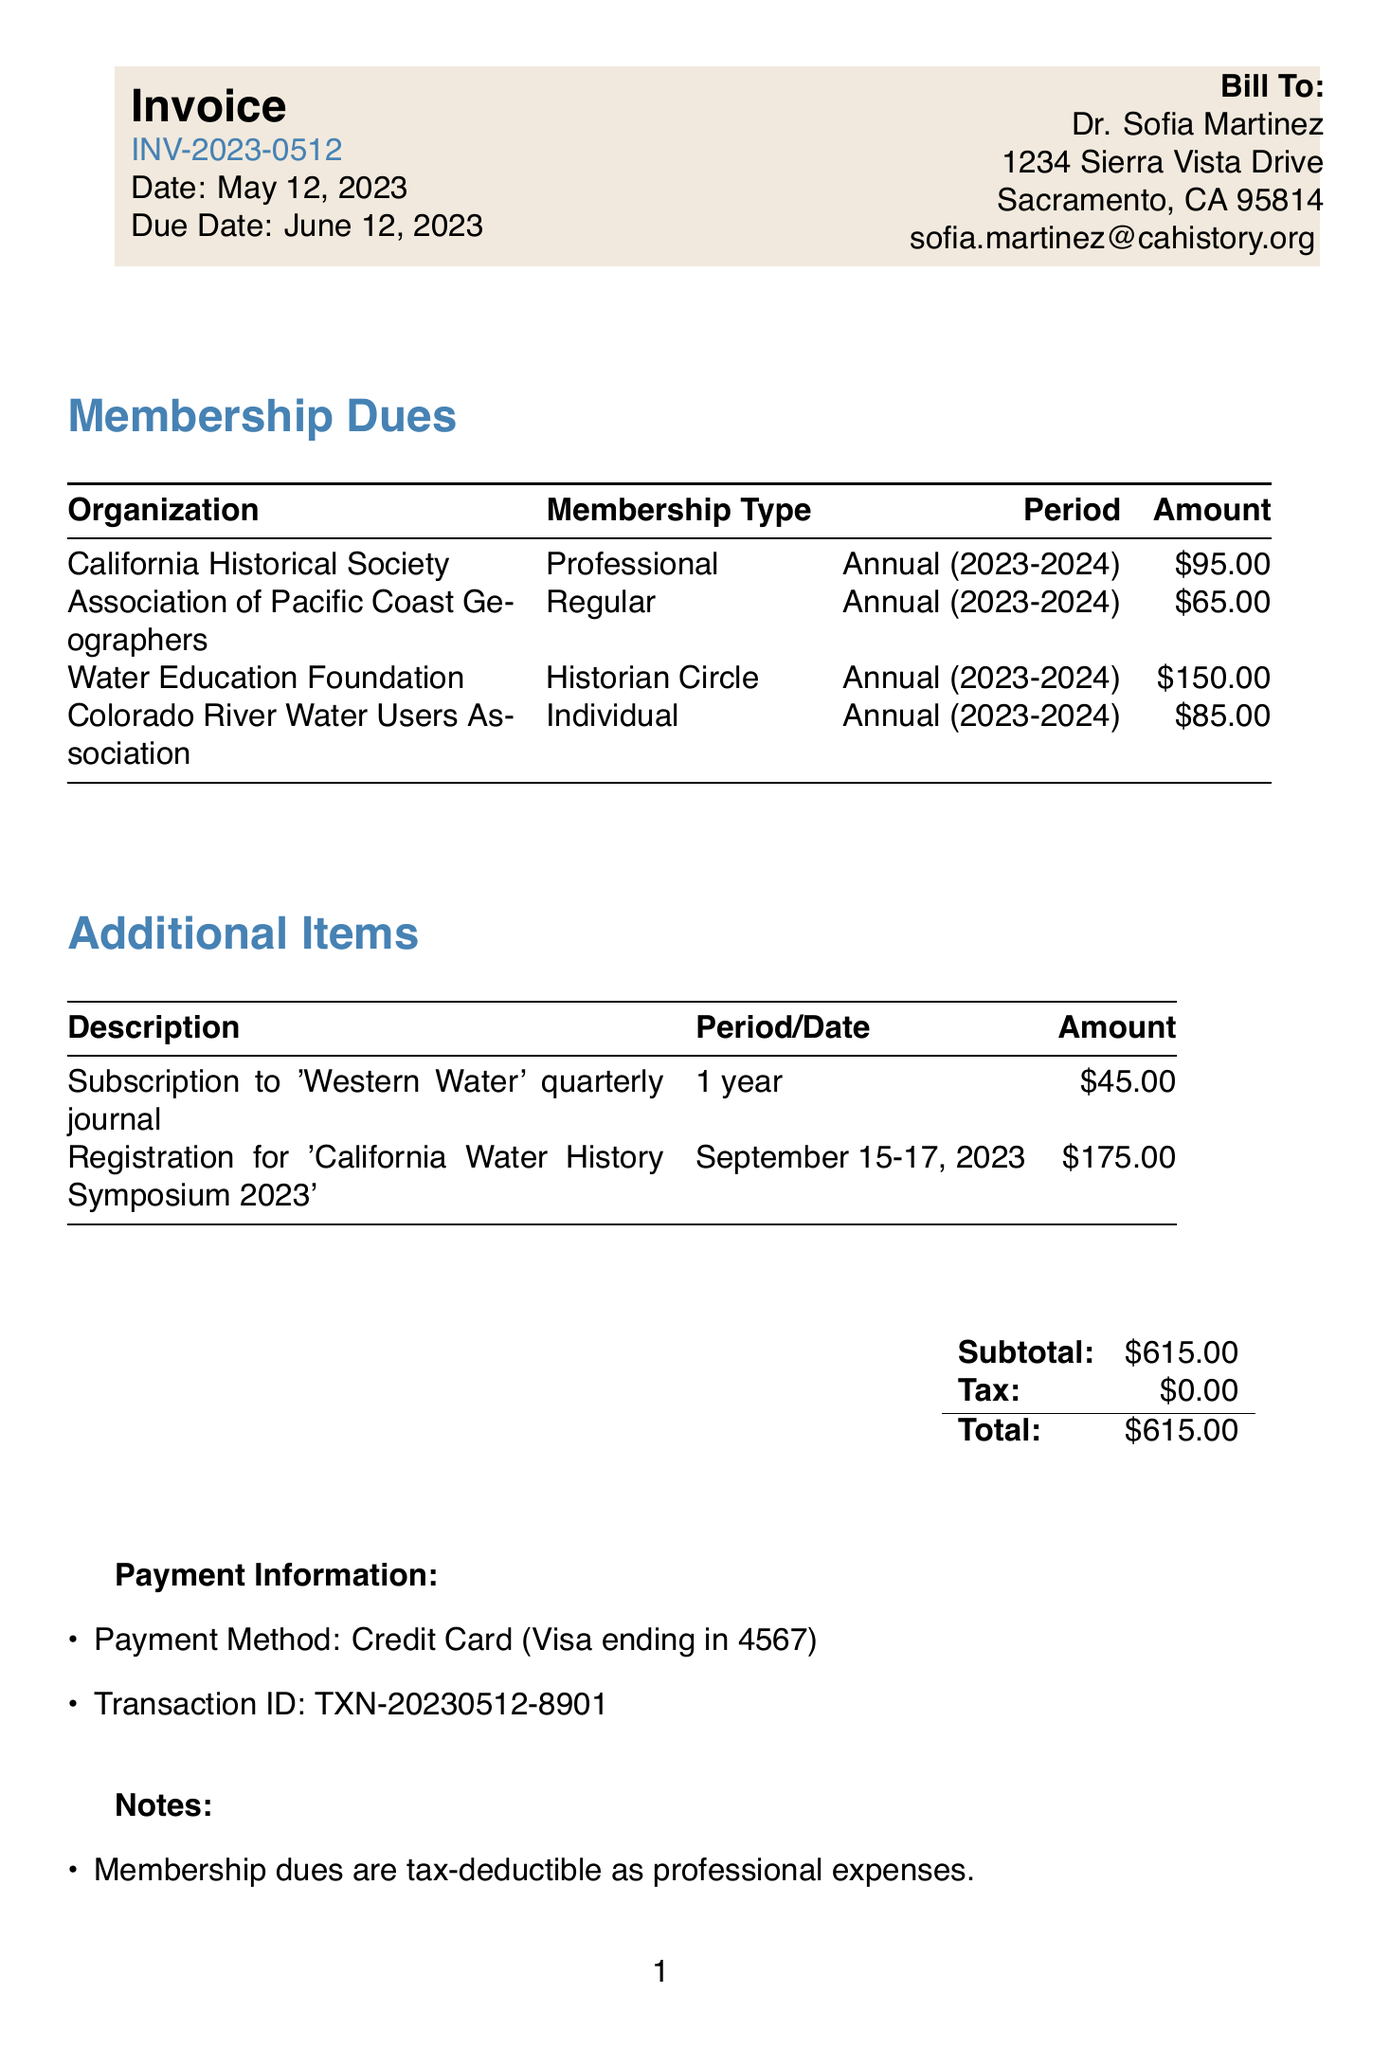What is the invoice number? The invoice number is stated clearly at the top of the document.
Answer: INV-2023-0512 What is the total amount due? The total amount due is calculated at the end of the invoice, including all membership dues and additional items.
Answer: $615.00 Who is the bill recipient? The recipient's name and address are found in the "Bill To" section of the invoice.
Answer: Dr. Sofia Martinez What is the period for the California Historical Society membership? The period is highlighted in the table alongside the organization and membership type.
Answer: Annual (2023-2024) What is the date of the California Water History Symposium? The date is specified in the description of the additional item on the invoice.
Answer: September 15-17, 2023 What payment method was used for the transaction? The payment method is listed under the payment information section near the bottom of the document.
Answer: Credit Card (Visa ending in 4567) How many organizations is Dr. Martinez a member of? The number is derived from counting the organizations listed in the membership dues section.
Answer: 4 Are the membership dues tax-deductible? This information is provided in the notes section, addressing the tax status of the dues.
Answer: Yes What is the subtotal of the invoice? The subtotal is clearly stated in the payment information section before adding tax.
Answer: $615.00 